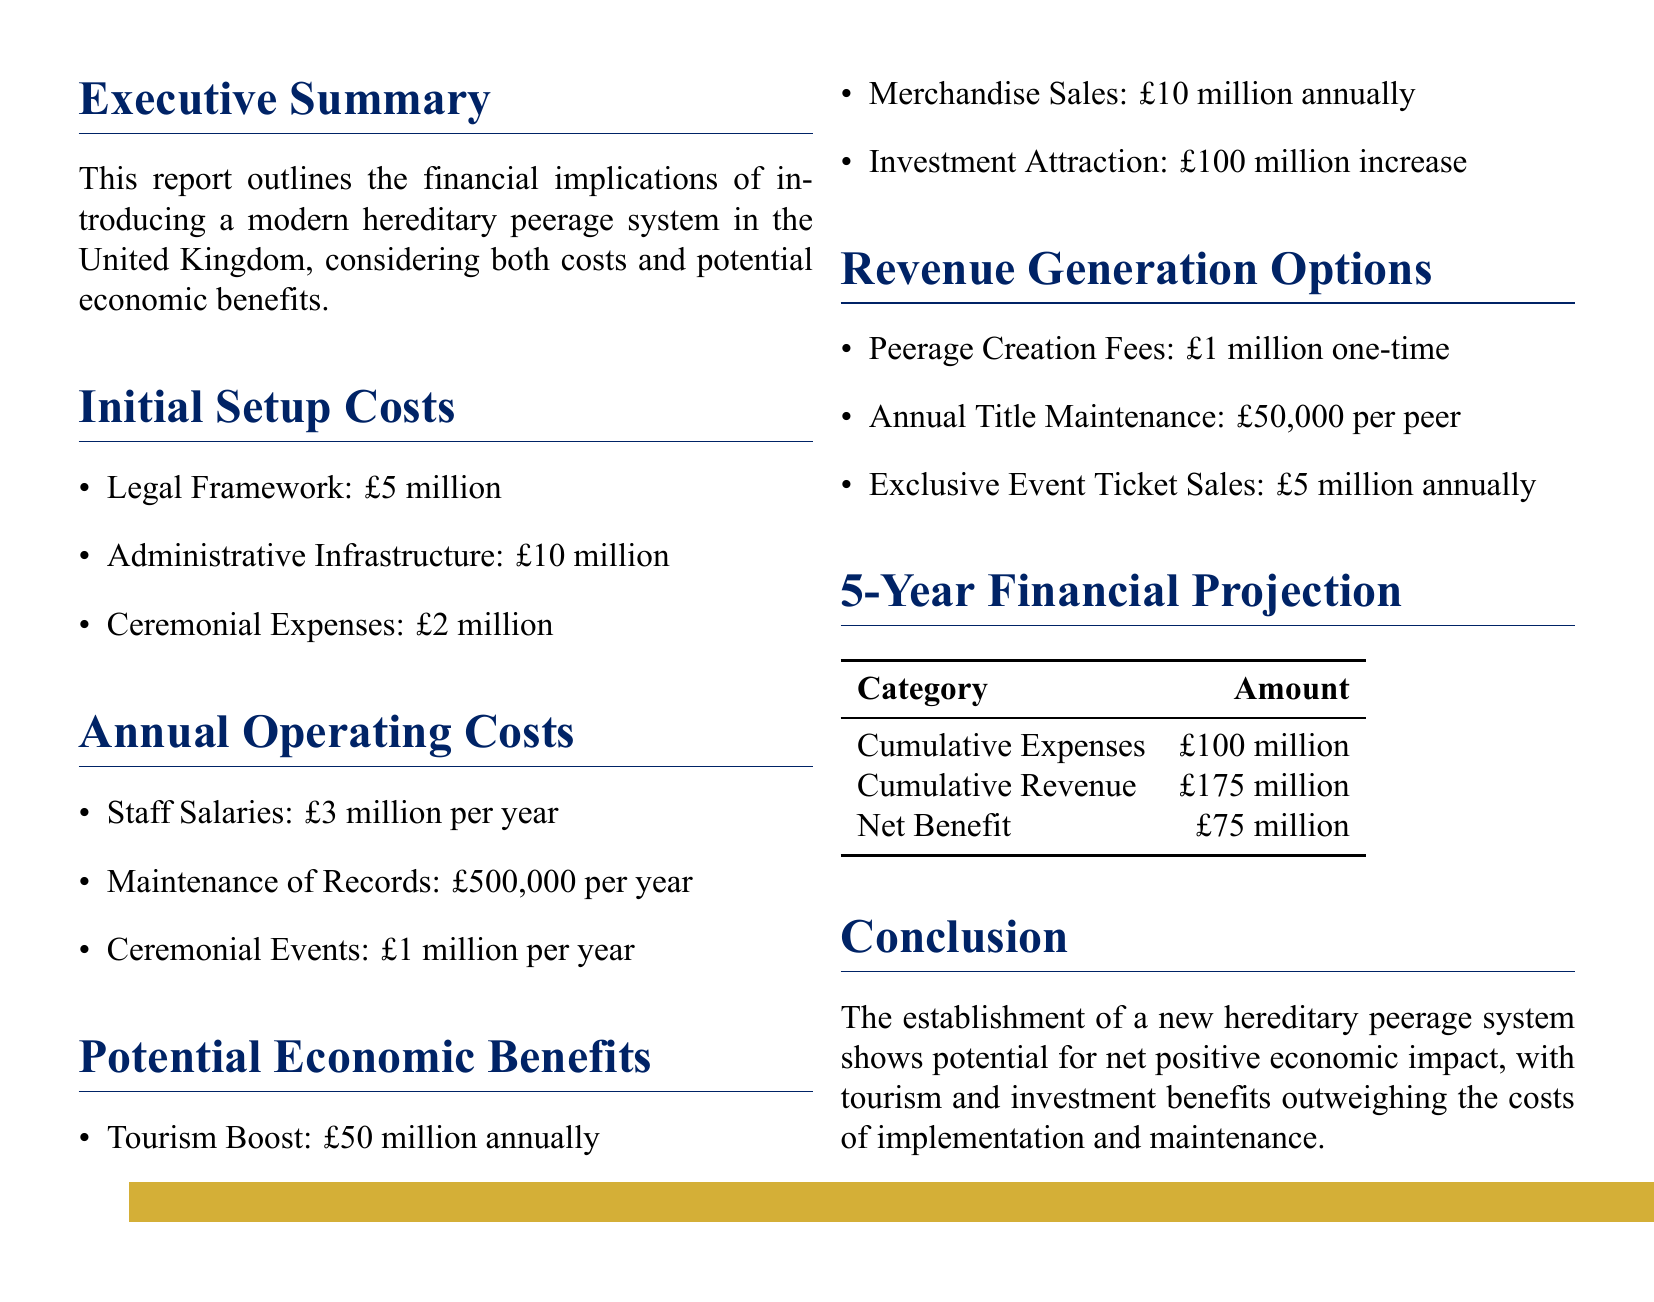What is the total initial setup cost? The initial setup cost is the sum of legal framework, administrative infrastructure, and ceremonial expenses, which totals £5 million + £10 million + £2 million.
Answer: £17 million What is the annual operating cost for staff salaries? The document specifies that staff salaries for the Peerage Office amount to £3 million per year.
Answer: £3 million What is the projected annual revenue from merchandise sales? The report estimates merchandise sales will generate £10 million annually.
Answer: £10 million What is the estimated increase in annual tourism revenue? The document states that the estimated boost in tourism revenue is £50 million annually.
Answer: £50 million What is the net benefit after 5 years? The net benefit after 5 years is calculated as the difference between cumulative revenue and cumulative expenses, resulting in £175 million - £100 million.
Answer: £75 million What is the total cost over 5 years? The total cost over 5 years is a cumulative expense of £100 million as stated in the long-term financial projection.
Answer: £100 million How much would a one-time fee for creating a new hereditary peerage be? The document indicates that the one-time fee for peerage creation is £1 million.
Answer: £1 million What is the annual revenue from exclusive event ticket sales? The annual revenue generated from exclusive event ticket sales is projected to be £5 million.
Answer: £5 million What is the cost of maintenance of records per year? The document outlines that the cost of maintaining records is £500,000 per year.
Answer: £500,000 